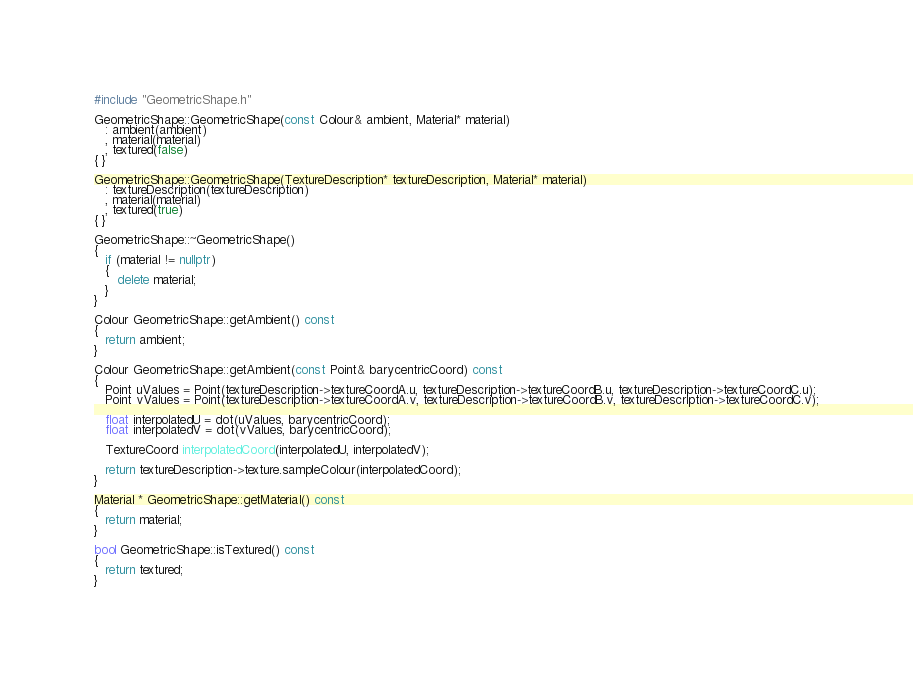<code> <loc_0><loc_0><loc_500><loc_500><_C++_>#include "GeometricShape.h"

GeometricShape::GeometricShape(const Colour& ambient, Material* material)
   : ambient(ambient)
   , material(material)
   , textured(false)
{ }

GeometricShape::GeometricShape(TextureDescription* textureDescription, Material* material)
   : textureDescription(textureDescription)
   , material(material)
   , textured(true)
{ }

GeometricShape::~GeometricShape()
{
   if (material != nullptr)
   {
      delete material;
   }
}

Colour GeometricShape::getAmbient() const
{
   return ambient;
}

Colour GeometricShape::getAmbient(const Point& barycentricCoord) const
{
   Point uValues = Point(textureDescription->textureCoordA.u, textureDescription->textureCoordB.u, textureDescription->textureCoordC.u);
   Point vValues = Point(textureDescription->textureCoordA.v, textureDescription->textureCoordB.v, textureDescription->textureCoordC.v);

   float interpolatedU = dot(uValues, barycentricCoord);
   float interpolatedV = dot(vValues, barycentricCoord);

   TextureCoord interpolatedCoord(interpolatedU, interpolatedV);

   return textureDescription->texture.sampleColour(interpolatedCoord);
}

Material * GeometricShape::getMaterial() const
{
   return material;
}

bool GeometricShape::isTextured() const
{
   return textured;
}

</code> 